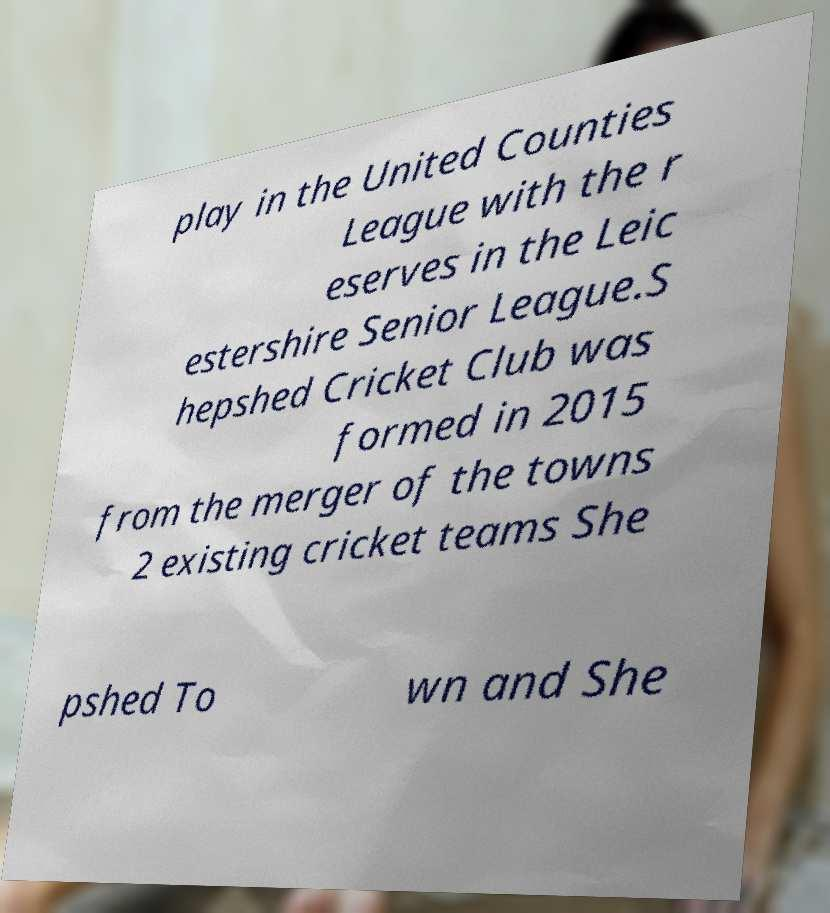Could you extract and type out the text from this image? play in the United Counties League with the r eserves in the Leic estershire Senior League.S hepshed Cricket Club was formed in 2015 from the merger of the towns 2 existing cricket teams She pshed To wn and She 